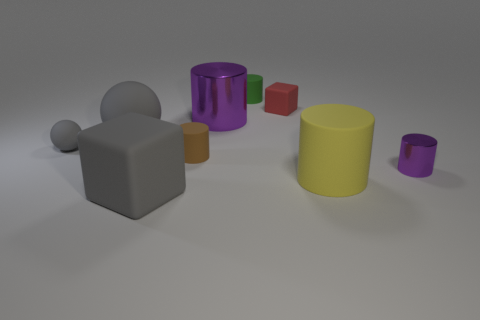Can you describe the texture on the objects? The objects have a relatively smooth and matte texture, with very slight specular highlights indicating they are not overly shiny. The appearance is consistent with a non-reflective, perhaps plastic-like material. Do all objects share the same finish? Most objects share the same finish, though the larger purple and smaller magenta cylinders seem to have a slightly glossier surface compared to the others. 